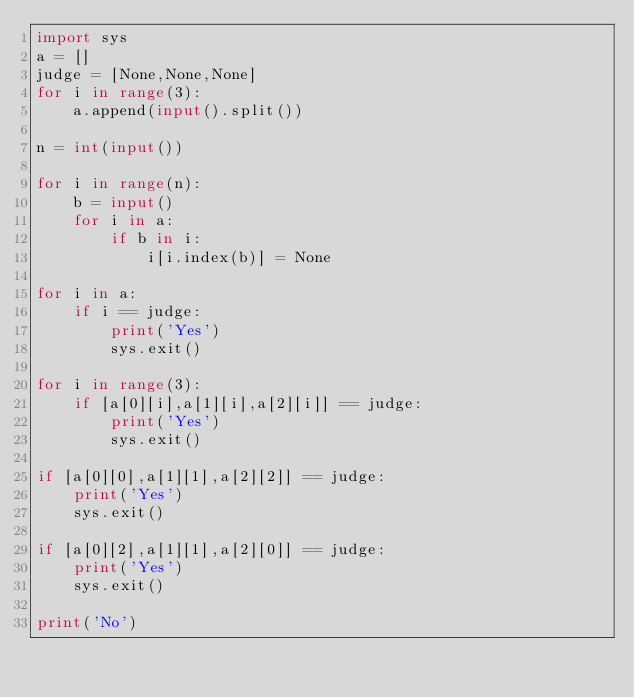Convert code to text. <code><loc_0><loc_0><loc_500><loc_500><_Python_>import sys
a = []
judge = [None,None,None]
for i in range(3):
    a.append(input().split())

n = int(input())

for i in range(n):
    b = input()
    for i in a:
        if b in i:
            i[i.index(b)] = None

for i in a:
    if i == judge:
        print('Yes')
        sys.exit()

for i in range(3):
    if [a[0][i],a[1][i],a[2][i]] == judge:
        print('Yes')
        sys.exit()

if [a[0][0],a[1][1],a[2][2]] == judge:
    print('Yes')
    sys.exit()

if [a[0][2],a[1][1],a[2][0]] == judge:
    print('Yes')
    sys.exit()

print('No')

</code> 